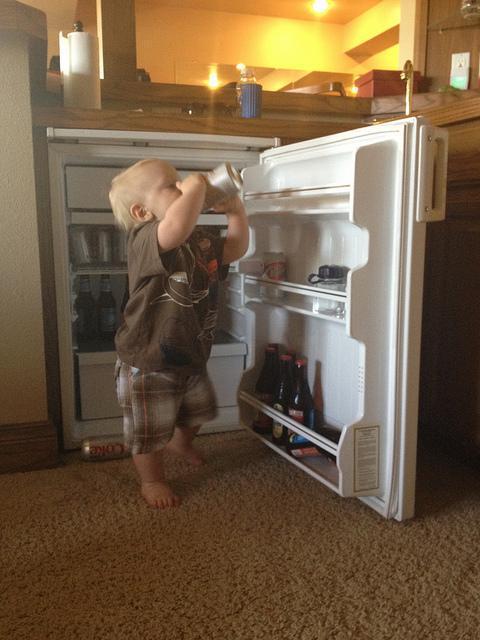How many people are in the picture?
Give a very brief answer. 1. How many black dog in the image?
Give a very brief answer. 0. 